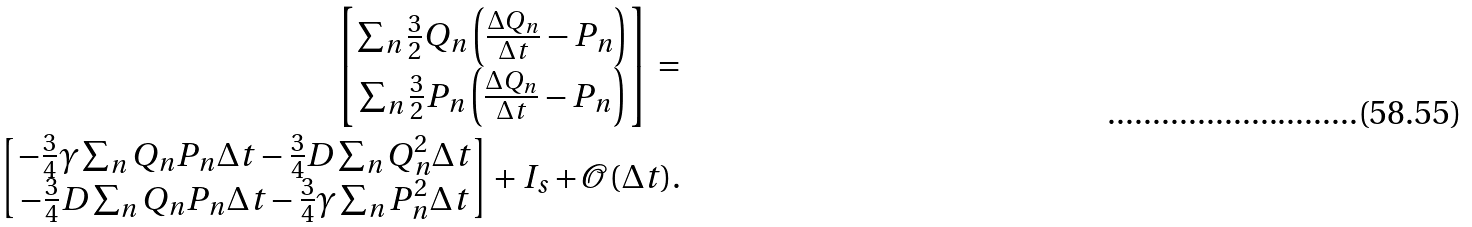Convert formula to latex. <formula><loc_0><loc_0><loc_500><loc_500>\begin{bmatrix} \sum _ { n } \frac { 3 } { 2 } Q _ { n } \left ( \frac { \Delta Q _ { n } } { \Delta t } - P _ { n } \right ) \\ \sum _ { n } \frac { 3 } { 2 } P _ { n } \left ( \frac { \Delta Q _ { n } } { \Delta t } - P _ { n } \right ) \end{bmatrix} = \\ \begin{bmatrix} - \frac { 3 } { 4 } \gamma \sum _ { n } Q _ { n } P _ { n } \Delta t - \frac { 3 } { 4 } D \sum _ { n } Q _ { n } ^ { 2 } \Delta t \\ - \frac { 3 } { 4 } D \sum _ { n } Q _ { n } P _ { n } \Delta t - \frac { 3 } { 4 } \gamma \sum _ { n } P _ { n } ^ { 2 } \Delta t \end{bmatrix} + I _ { s } + \mathcal { O } ( \Delta t ) .</formula> 